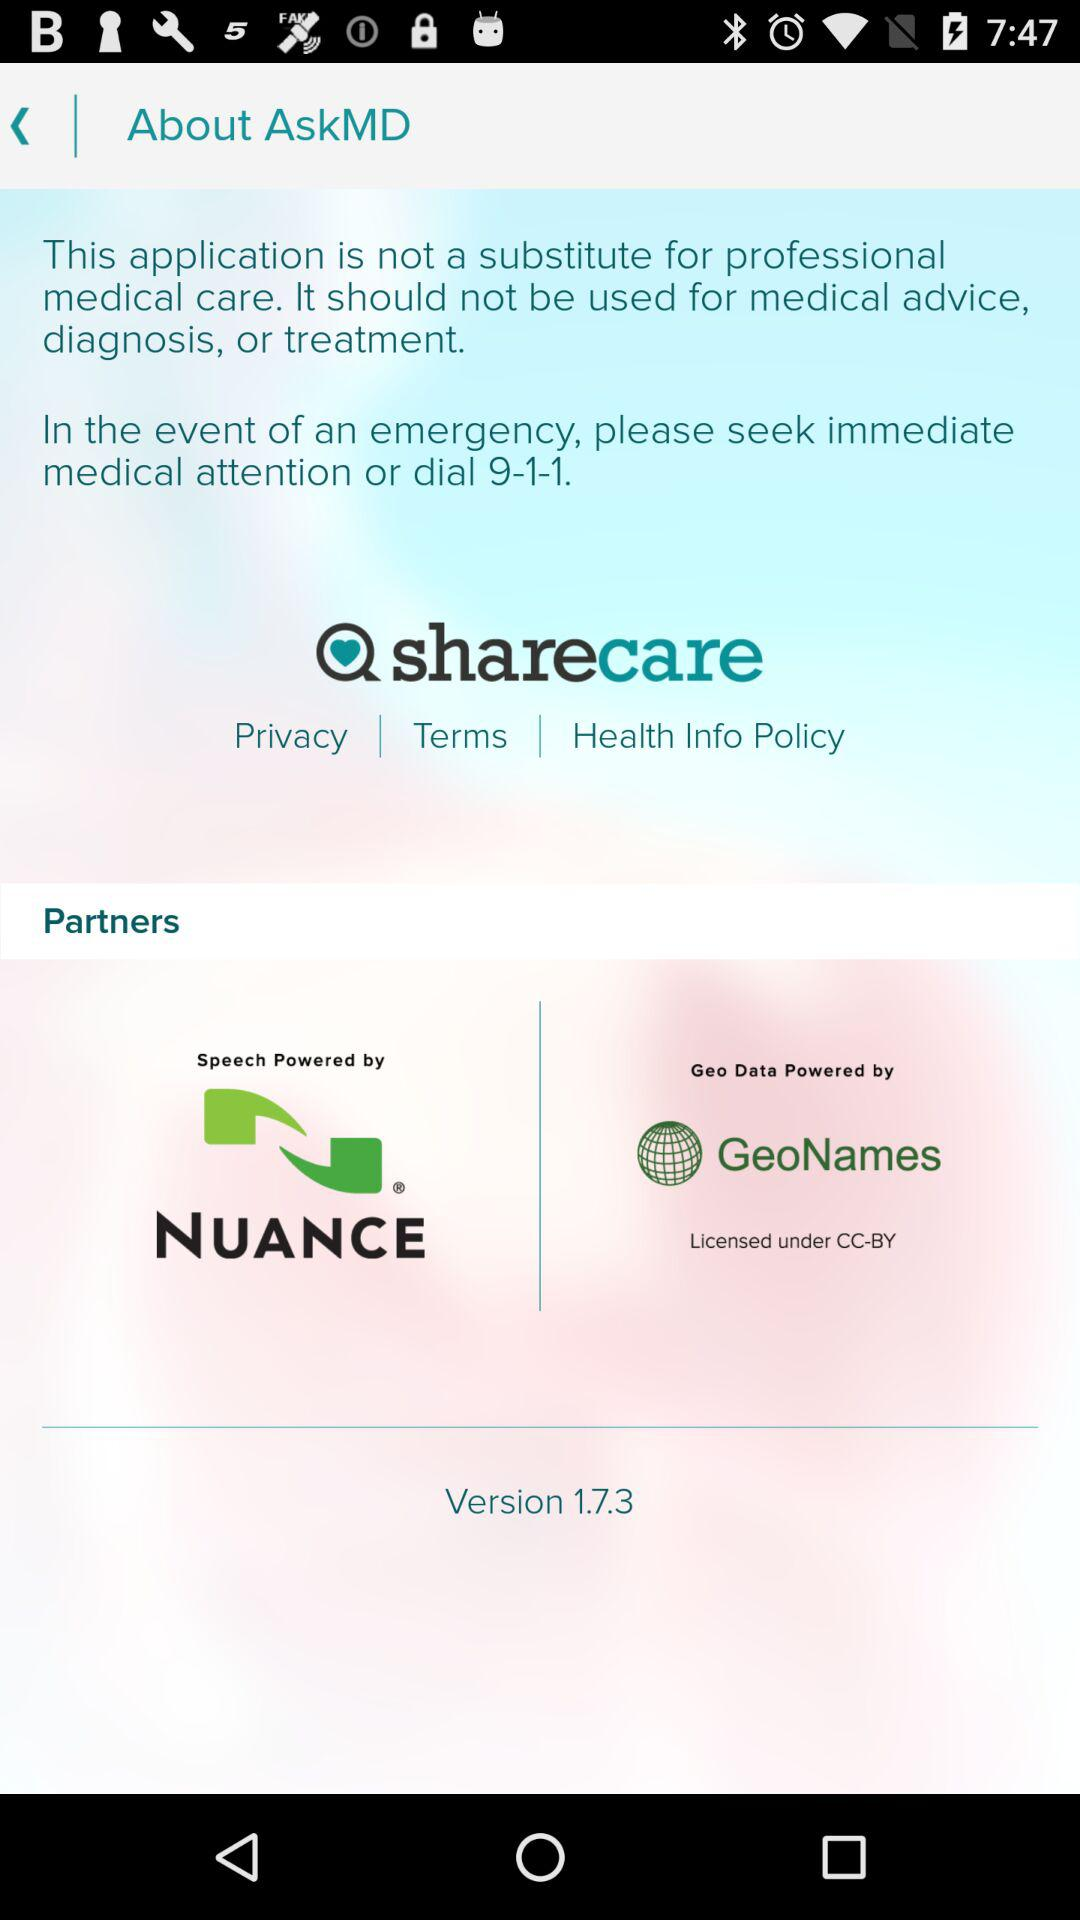What is the emergency number for medical attention? The emergency number for medical attention is 9-1-1. 